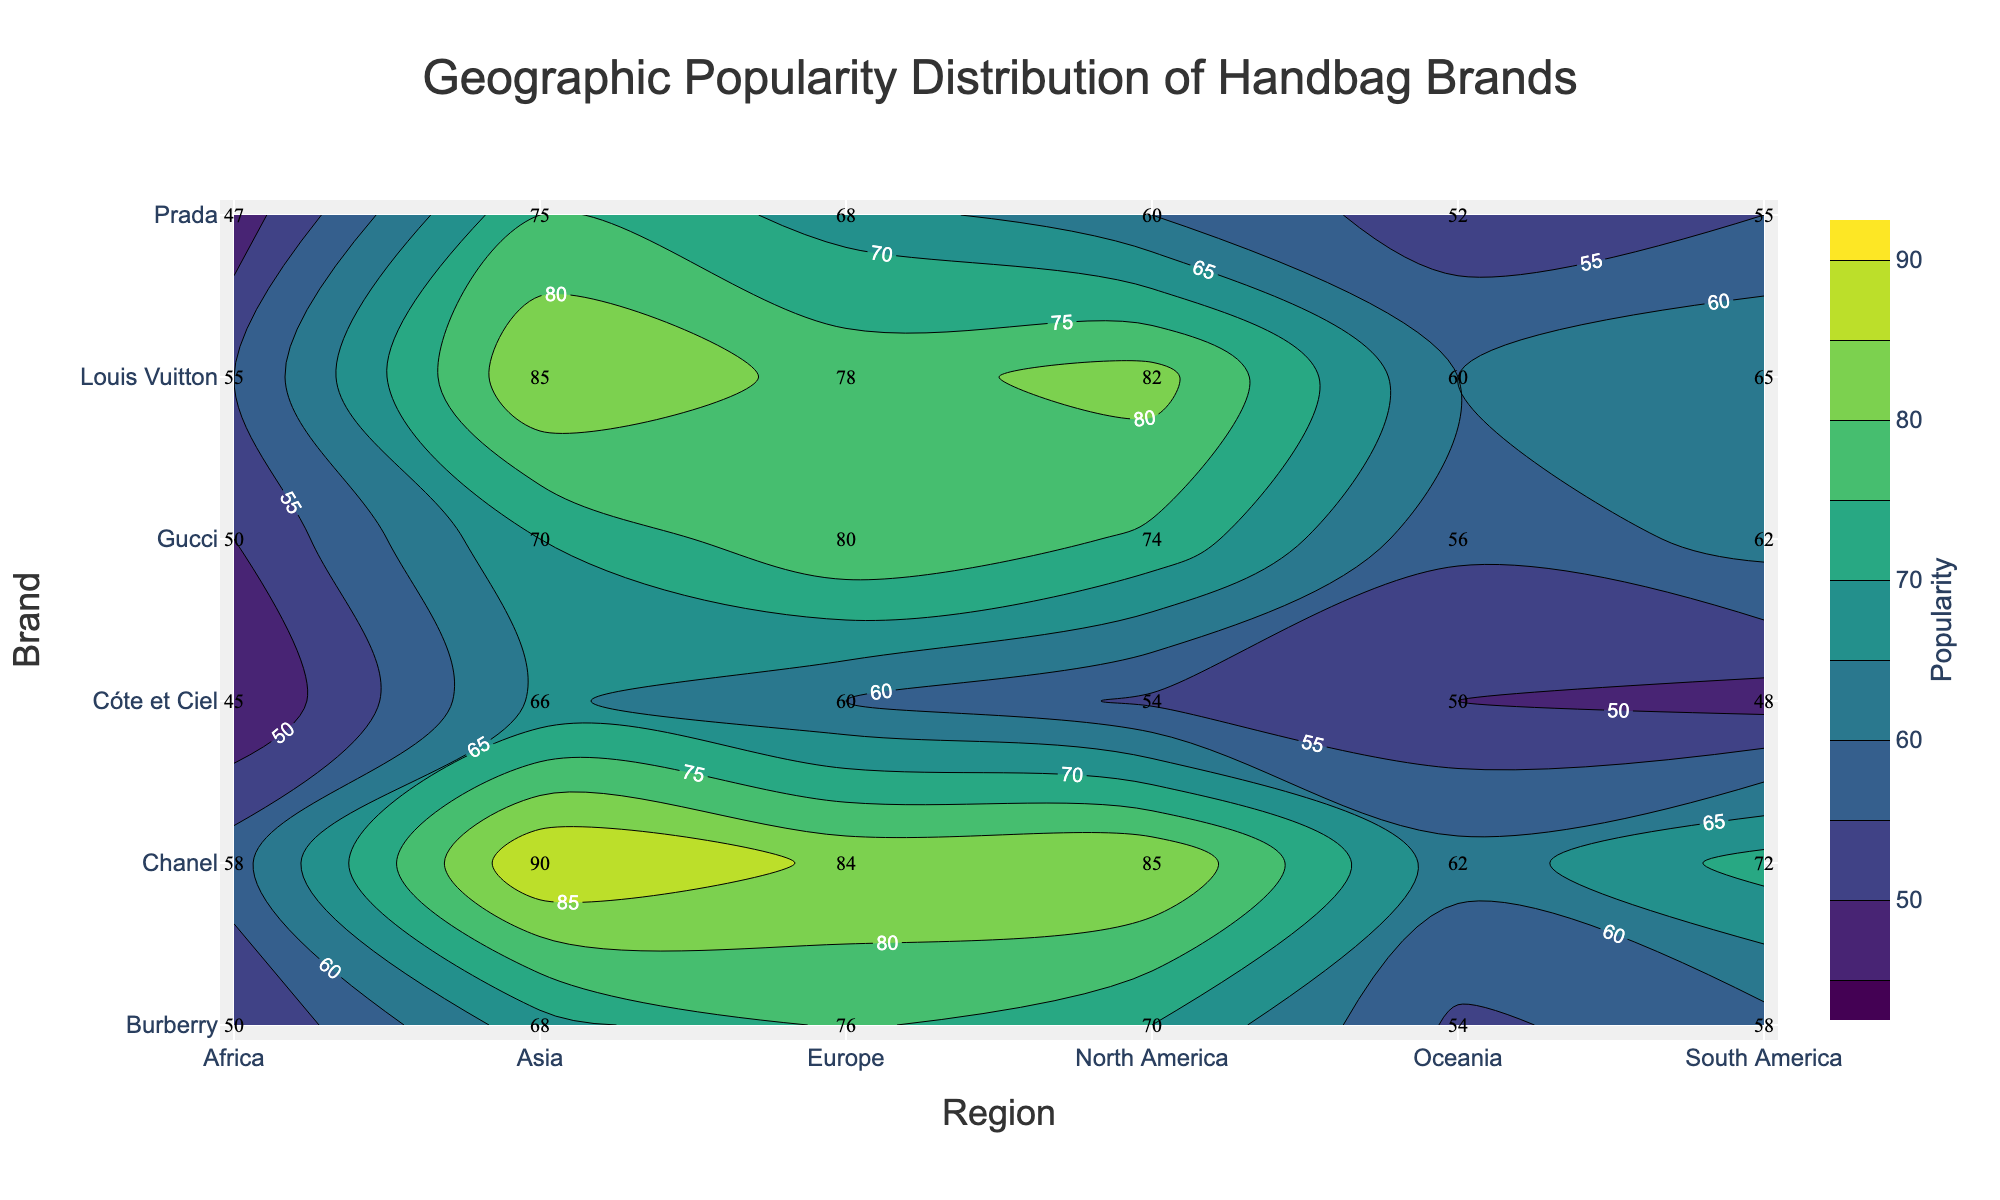What is the title of the plot? The title of the plot is located at the top center of the figure. It reads "Geographic Popularity Distribution of Handbag Brands".
Answer: Geographic Popularity Distribution of Handbag Brands Which region has the highest popularity for Chanel? By looking at the contour plot, we can see the highest value for Chanel corresponds to the region with the highest value. For Chanel, this value is 90 in Asia.
Answer: Asia How does Burberry's popularity in Europe compare to its popularity in Africa? Burberry's popularity in Europe is 76, while in Africa it is 50. By comparing these values, we can see that Burberry is more popular in Europe than in Africa.
Answer: Europe is more popular What is the average popularity of Louis Vuitton across all regions? To find the average popularity of Louis Vuitton, we sum all the popularity values for each region and divide by the number of regions. (82 + 78 + 85 + 65 + 55 + 60) / 6 = 425 / 6 = 70.83
Answer: 70.83 Which brand has the lowest popularity in North America? By checking the contour plot for the popularity values of each brand in North America, we see that Cóte et Ciel has the lowest value of 54.
Answer: Cóte et Ciel What region shows the highest overall popularity across all brands? By examining the contour levels and the labeled values, we notice that Asia consistently shows the highest popularity values across all brands, with values like 85, 70, 90, 75, 68, and 66.
Answer: Asia What is the difference between the highest and lowest popularity for Prada? The highest popularity for Prada is in Asia (75), and the lowest is in Africa (47). The difference is 75 - 47 = 28.
Answer: 28 Which brand shows the greatest variability in popularity across regions? By comparing the range of popularity values across regions for each brand, Chanel shows a high range from 58 in Africa to 90 in Asia, indicating high variability.
Answer: Chanel Does Louis Vuitton have higher popularity in Oceania or South America? By comparing the values for Louis Vuitton, we see that in South America, the value is 65 and in Oceania, it is 60. So, it's higher in South America.
Answer: South America What is the median popularity of Gucci across all regions? The popularity values across all regions for Gucci are 74, 80, 70, 62, 50, and 56. Ordering these values: 50, 56, 62, 70, 74, 80. The median is the average of the two middle numbers: (62 + 70) / 2 = 66.
Answer: 66 